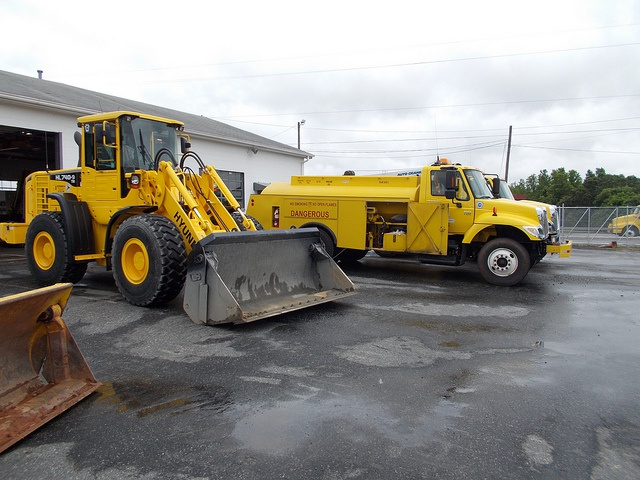Describe the objects in this image and their specific colors. I can see truck in white, black, olive, and gold tones, truck in white, lightgray, darkgray, gray, and black tones, and truck in white, tan, gray, and darkgray tones in this image. 